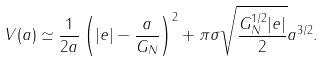Convert formula to latex. <formula><loc_0><loc_0><loc_500><loc_500>V ( a ) \simeq \frac { 1 } { 2 a } \left ( | e | - \frac { a } { G _ { N } } \right ) ^ { 2 } + \pi \sigma \sqrt { \frac { G _ { N } ^ { 1 / 2 } | e | } { 2 } } a ^ { 3 / 2 } .</formula> 